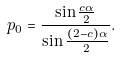<formula> <loc_0><loc_0><loc_500><loc_500>p _ { 0 } = \frac { \sin \frac { c \alpha } { 2 } } { \sin \frac { ( 2 - c ) \alpha } { 2 } } .</formula> 